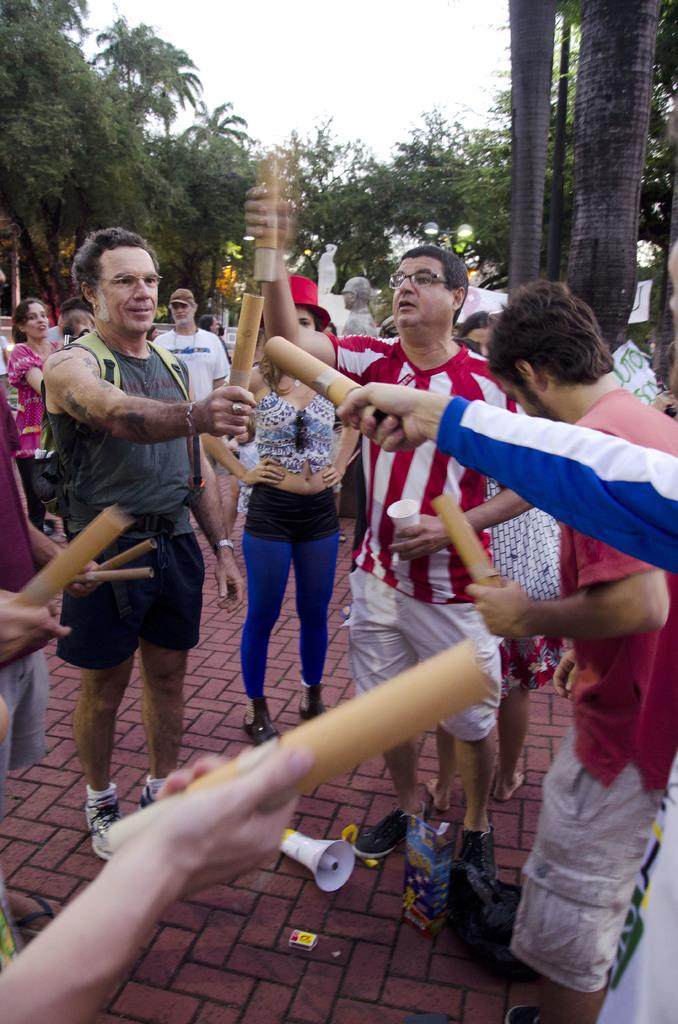What is happening in the image involving a group of people? There is a group of people in the image, and they are holding something in their hands. What can be found on the ground in the image? There are objects on the ground in the image. What is visible in the background of the image? There are trees and the sky visible in the background of the image. What type of rail is being used by the people in the image? There is no rail present in the image; the people are holding something in their hands. How does the zipper on the people's clothing help them learn in the image? There is no mention of learning or zippers in the image; it features a group of people holding something in their hands, with objects on the ground, and trees and sky in the background. 